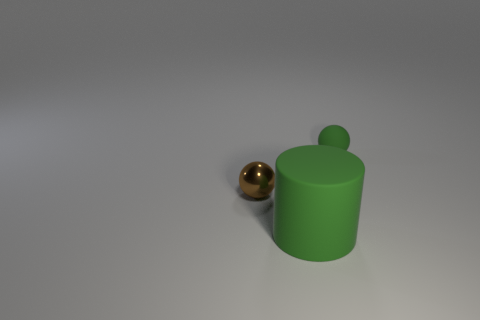Add 1 red matte cylinders. How many objects exist? 4 Subtract all spheres. How many objects are left? 1 Subtract all green rubber balls. Subtract all brown objects. How many objects are left? 1 Add 2 green spheres. How many green spheres are left? 3 Add 2 big yellow matte objects. How many big yellow matte objects exist? 2 Subtract 1 green cylinders. How many objects are left? 2 